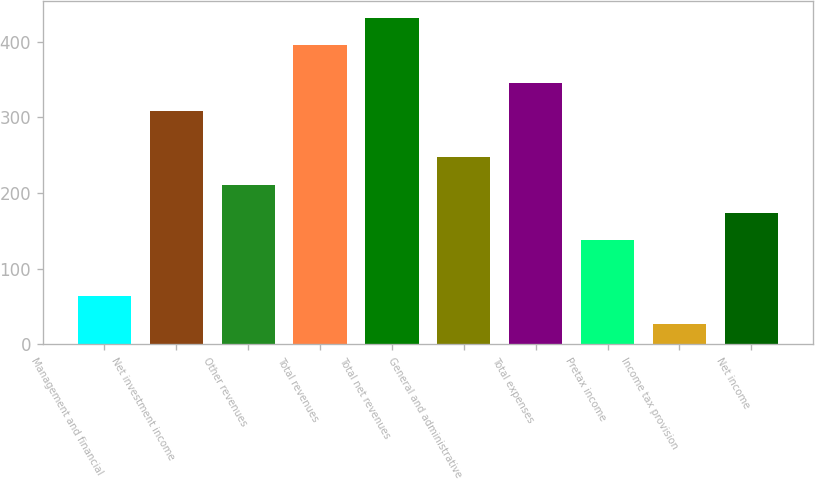Convert chart to OTSL. <chart><loc_0><loc_0><loc_500><loc_500><bar_chart><fcel>Management and financial<fcel>Net investment income<fcel>Other revenues<fcel>Total revenues<fcel>Total net revenues<fcel>General and administrative<fcel>Total expenses<fcel>Pretax income<fcel>Income tax provision<fcel>Net income<nl><fcel>63.8<fcel>308<fcel>211<fcel>395<fcel>431.8<fcel>247.8<fcel>344.8<fcel>137.4<fcel>27<fcel>174.2<nl></chart> 